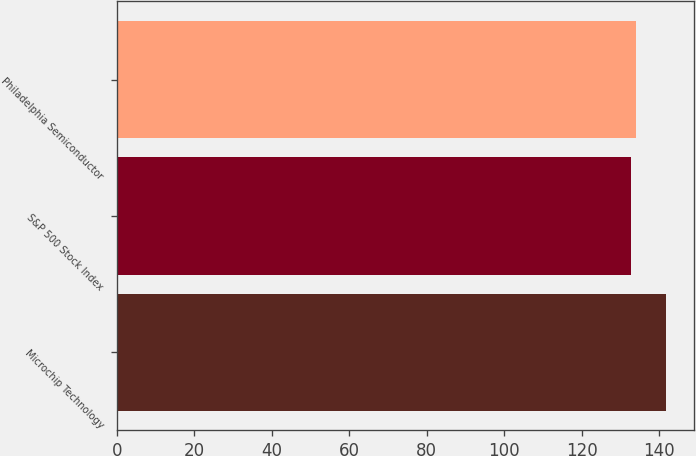Convert chart to OTSL. <chart><loc_0><loc_0><loc_500><loc_500><bar_chart><fcel>Microchip Technology<fcel>S&P 500 Stock Index<fcel>Philadelphia Semiconductor<nl><fcel>141.78<fcel>132.64<fcel>133.9<nl></chart> 